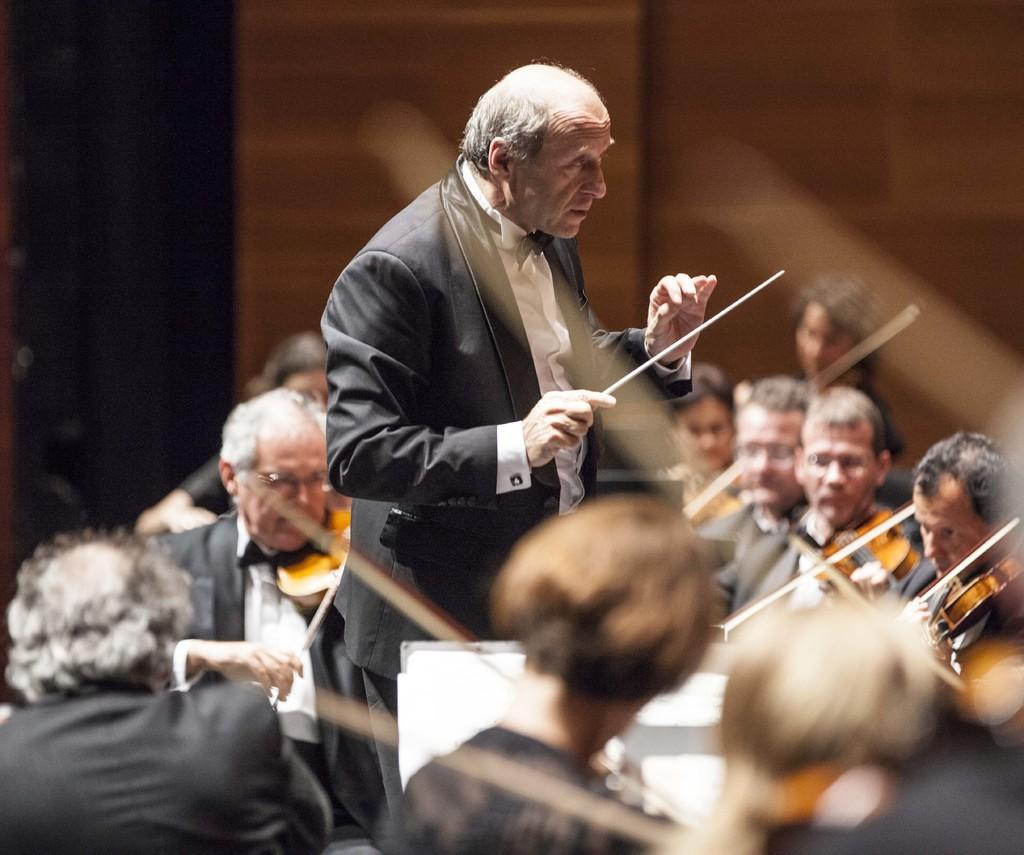What is the main subject of the image? There is a person standing at the center of the image. What is the person wearing? The person is wearing a suit. What is the person holding in the image? The person is holding a stick. What are the other people in the image doing? The seated people are playing violins. What type of calculator can be seen on the person's lap in the image? There is no calculator present in the image. How does the person compare to the other musicians in the image? The image does not provide any information for comparison between the person and the other musicians. 